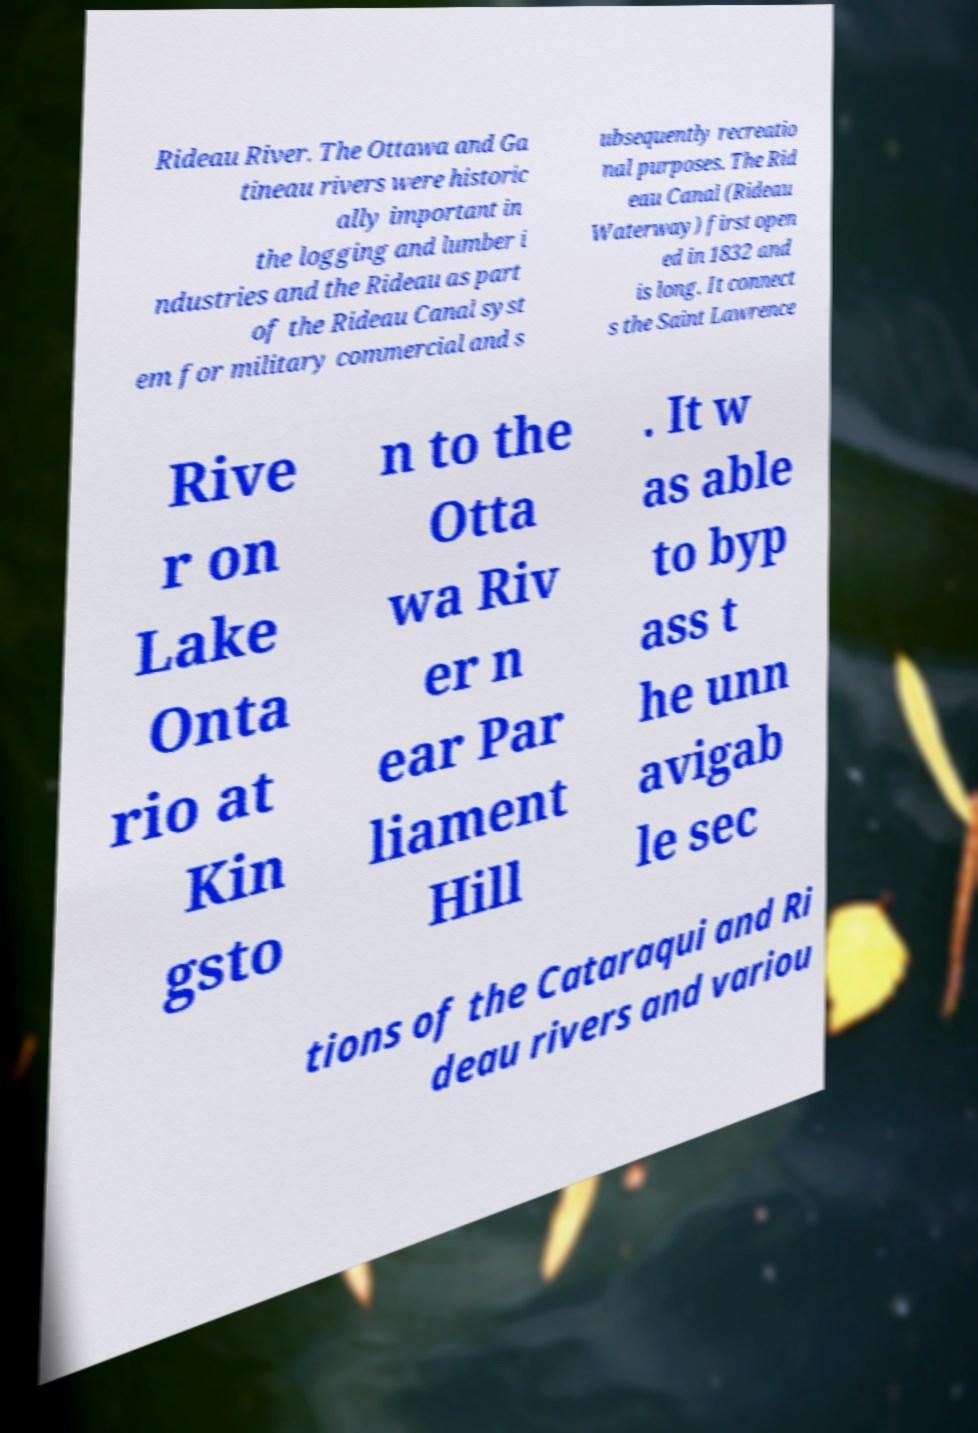Can you accurately transcribe the text from the provided image for me? Rideau River. The Ottawa and Ga tineau rivers were historic ally important in the logging and lumber i ndustries and the Rideau as part of the Rideau Canal syst em for military commercial and s ubsequently recreatio nal purposes. The Rid eau Canal (Rideau Waterway) first open ed in 1832 and is long. It connect s the Saint Lawrence Rive r on Lake Onta rio at Kin gsto n to the Otta wa Riv er n ear Par liament Hill . It w as able to byp ass t he unn avigab le sec tions of the Cataraqui and Ri deau rivers and variou 